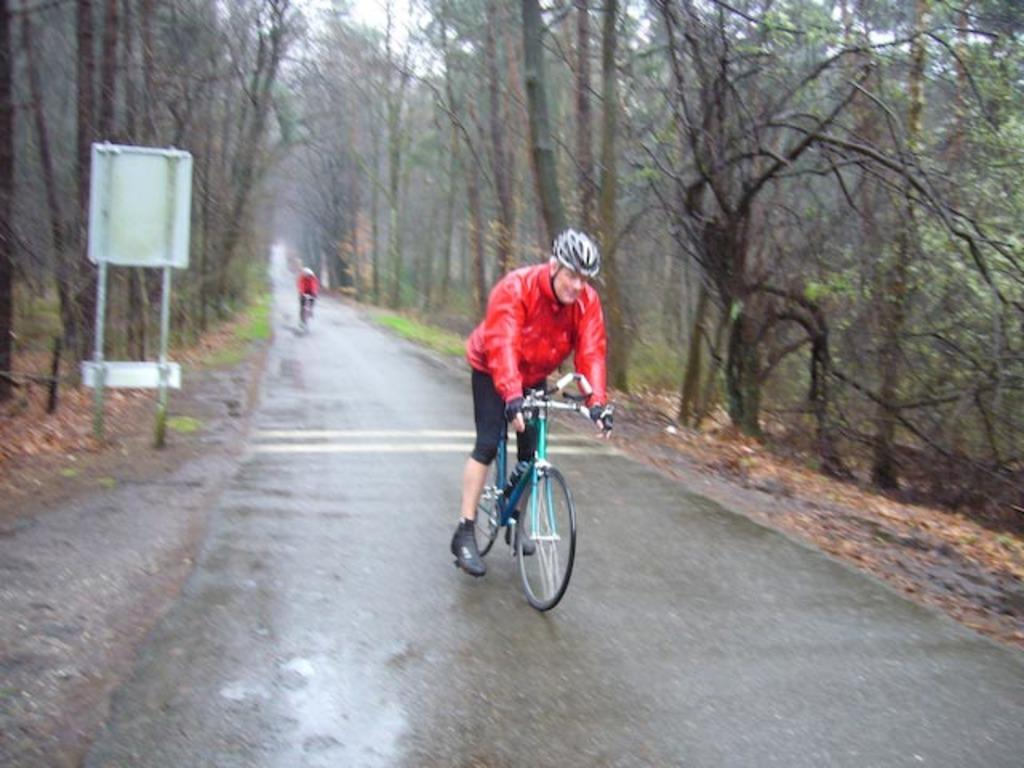What is the man in the image doing? The man is riding a bicycle in the image. What safety precaution is the man taking while riding the bicycle? The man is wearing a helmet. What type of surface can be seen in the image? There is a road visible in the image. What are the boards on poles in the image used for? The purpose of the boards on poles is not specified in the image. Can you describe the background of the image? In the background of the image, there is a person riding a bicycle, trees, and the sky. What type of toy is the man playing with while riding the bicycle? There is no toy visible in the image; the man is simply riding a bicycle. 